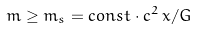Convert formula to latex. <formula><loc_0><loc_0><loc_500><loc_500>m \geq m _ { s } = c o n s t \cdot c ^ { 2 } \, x / G</formula> 